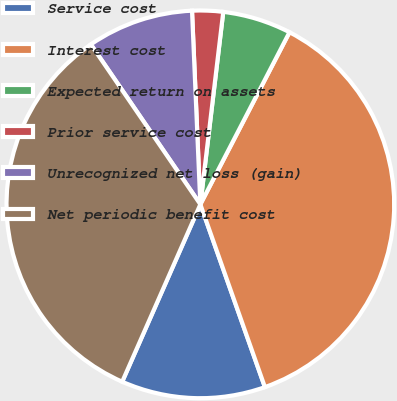<chart> <loc_0><loc_0><loc_500><loc_500><pie_chart><fcel>Service cost<fcel>Interest cost<fcel>Expected return on assets<fcel>Prior service cost<fcel>Unrecognized net loss (gain)<fcel>Net periodic benefit cost<nl><fcel>12.01%<fcel>36.99%<fcel>5.72%<fcel>2.57%<fcel>8.87%<fcel>33.84%<nl></chart> 